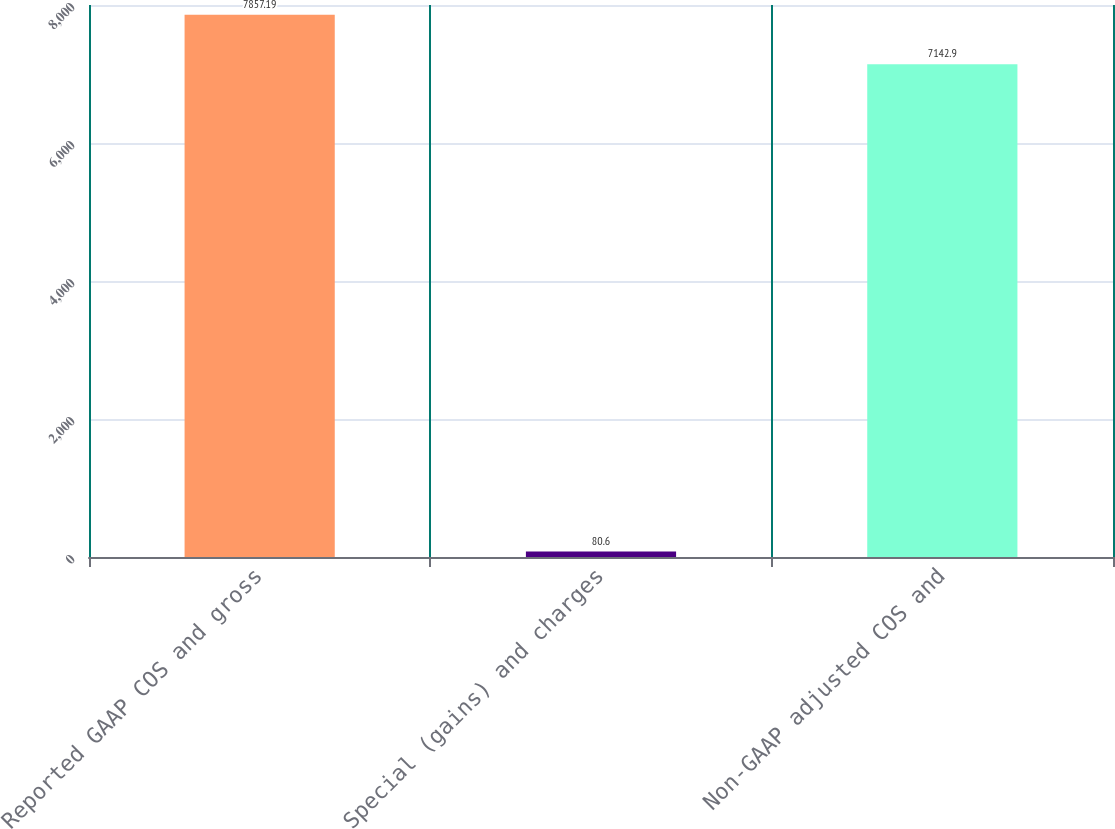Convert chart to OTSL. <chart><loc_0><loc_0><loc_500><loc_500><bar_chart><fcel>Reported GAAP COS and gross<fcel>Special (gains) and charges<fcel>Non-GAAP adjusted COS and<nl><fcel>7857.19<fcel>80.6<fcel>7142.9<nl></chart> 